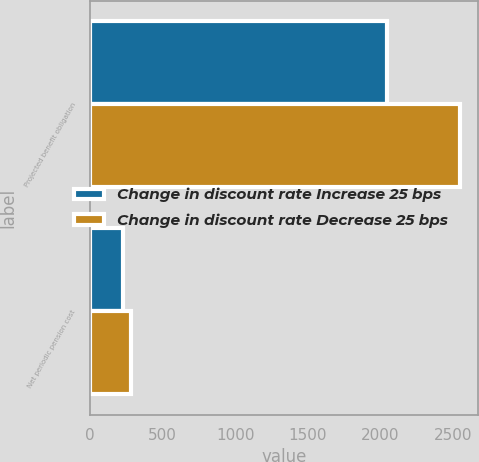Convert chart. <chart><loc_0><loc_0><loc_500><loc_500><stacked_bar_chart><ecel><fcel>Projected benefit obligation<fcel>Net periodic pension cost<nl><fcel>Change in discount rate Increase 25 bps<fcel>2043<fcel>227<nl><fcel>Change in discount rate Decrease 25 bps<fcel>2543<fcel>279<nl></chart> 